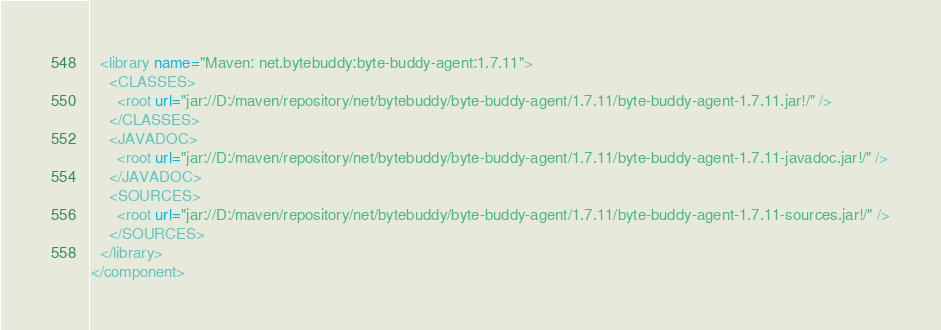<code> <loc_0><loc_0><loc_500><loc_500><_XML_>  <library name="Maven: net.bytebuddy:byte-buddy-agent:1.7.11">
    <CLASSES>
      <root url="jar://D:/maven/repository/net/bytebuddy/byte-buddy-agent/1.7.11/byte-buddy-agent-1.7.11.jar!/" />
    </CLASSES>
    <JAVADOC>
      <root url="jar://D:/maven/repository/net/bytebuddy/byte-buddy-agent/1.7.11/byte-buddy-agent-1.7.11-javadoc.jar!/" />
    </JAVADOC>
    <SOURCES>
      <root url="jar://D:/maven/repository/net/bytebuddy/byte-buddy-agent/1.7.11/byte-buddy-agent-1.7.11-sources.jar!/" />
    </SOURCES>
  </library>
</component></code> 